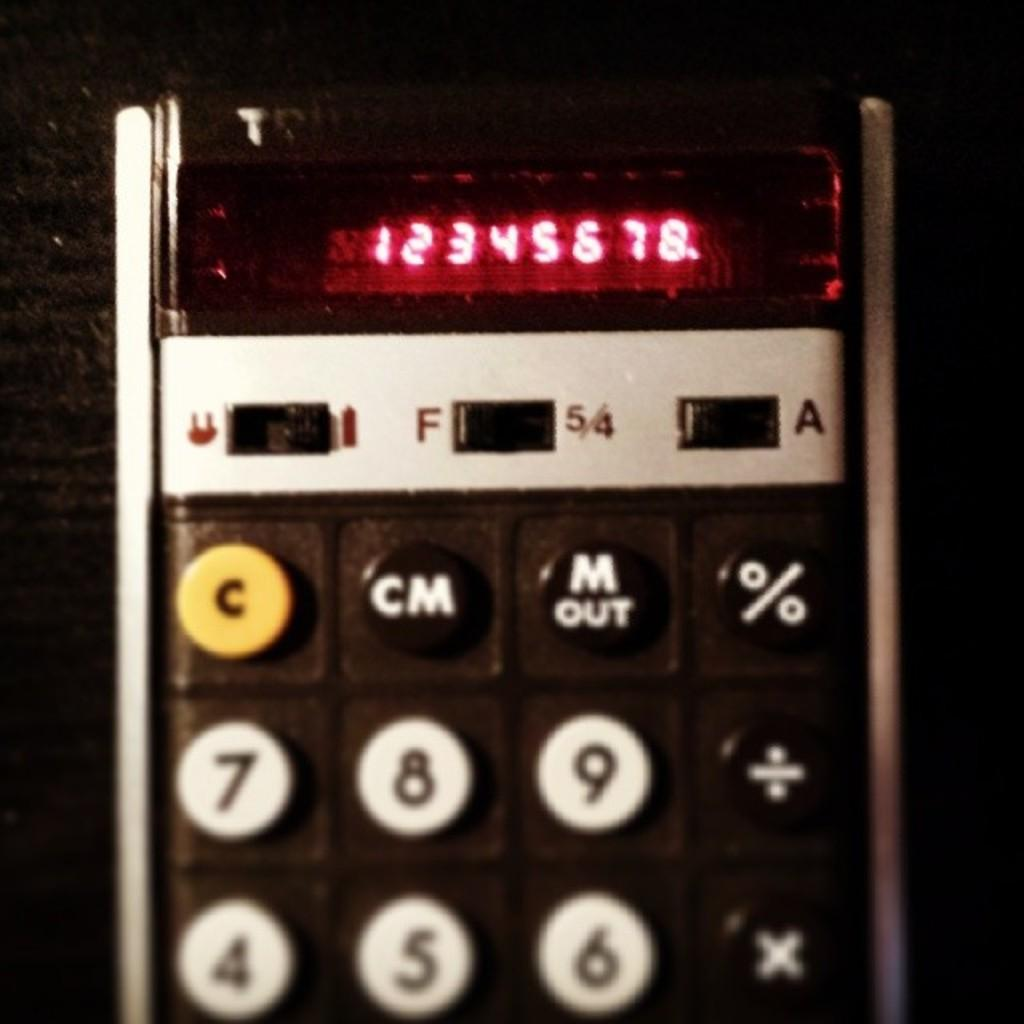<image>
Provide a brief description of the given image. A calculator that has 12345678 on it with a yellow c button 